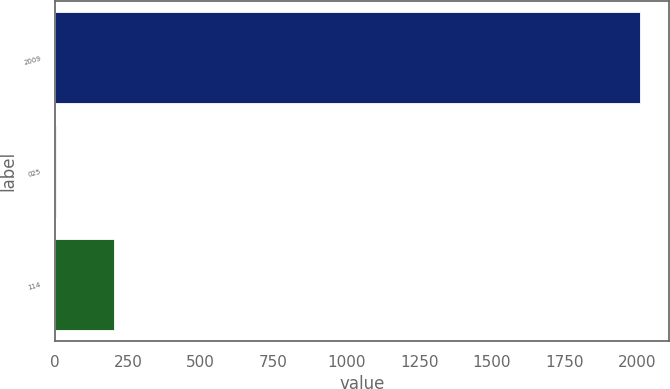Convert chart. <chart><loc_0><loc_0><loc_500><loc_500><bar_chart><fcel>2009<fcel>025<fcel>114<nl><fcel>2008<fcel>2.56<fcel>203.1<nl></chart> 